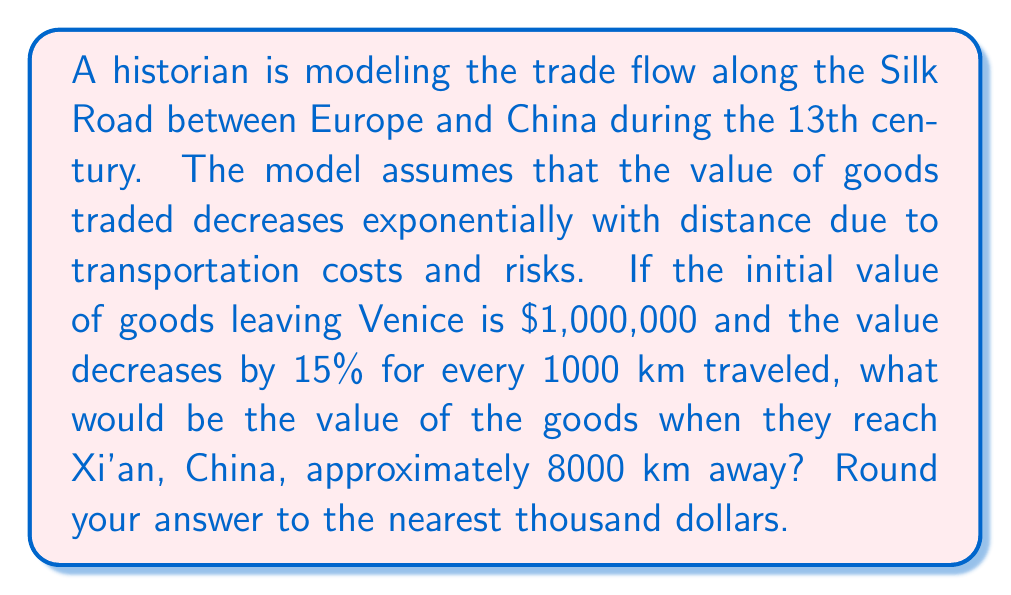Teach me how to tackle this problem. Let's approach this step-by-step:

1) First, we need to understand the exponential decay formula:
   $V = V_0 * (1-r)^{(d/1000)}$
   Where:
   $V$ = Final value
   $V_0$ = Initial value
   $r$ = Rate of decrease per 1000 km
   $d$ = Total distance in km

2) We're given:
   $V_0 = 1,000,000$
   $r = 0.15$ (15%)
   $d = 8000$ km

3) Let's substitute these values into our formula:
   $V = 1,000,000 * (1-0.15)^{(8000/1000)}$

4) Simplify the exponent:
   $V = 1,000,000 * (0.85)^8$

5) Calculate the result:
   $V = 1,000,000 * 0.2725995$
   $V = 272,599.50$

6) Rounding to the nearest thousand:
   $V ≈ 273,000$

This model demonstrates how the value of goods diminished over the long journey from Venice to Xi'an, reflecting the economic realities of long-distance trade during the Silk Road era.
Answer: $273,000 